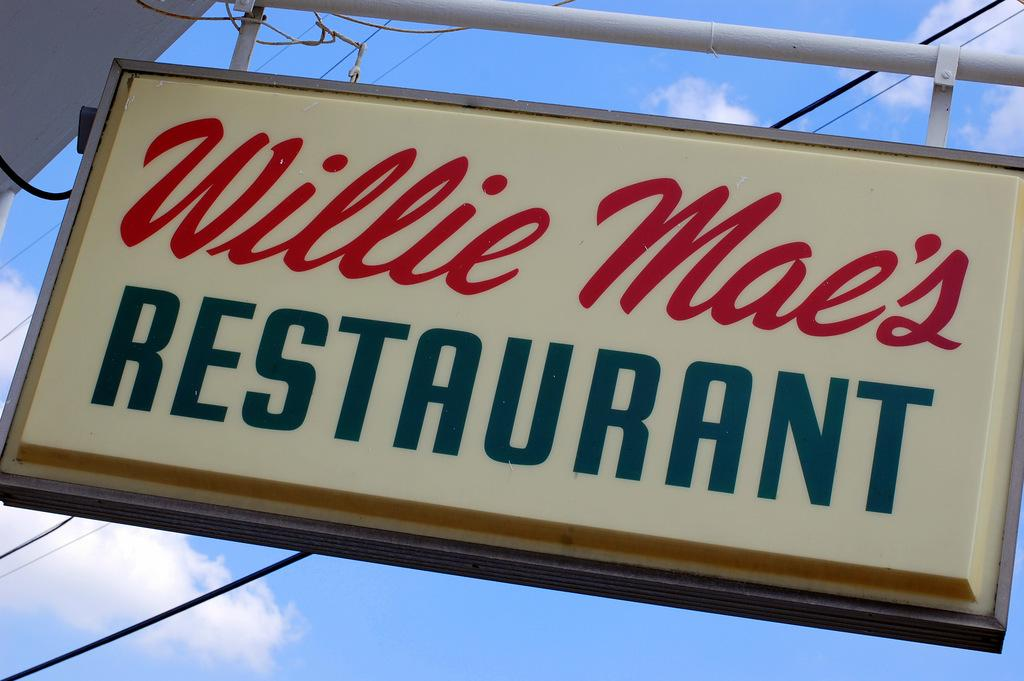What is the main subject of the image? The main subject of the image is a name board of a restaurant. How is the name board positioned in the image? The name board is hanging from a pole. What else can be seen in the image besides the name board? Cables are visible in the image. What is visible in the sky in the image? There are clouds in the sky in the image. How quiet is the noise level in the image? The image does not provide any information about the noise level, as it only shows a name board of a restaurant, a pole, cables, and clouds in the sky. 